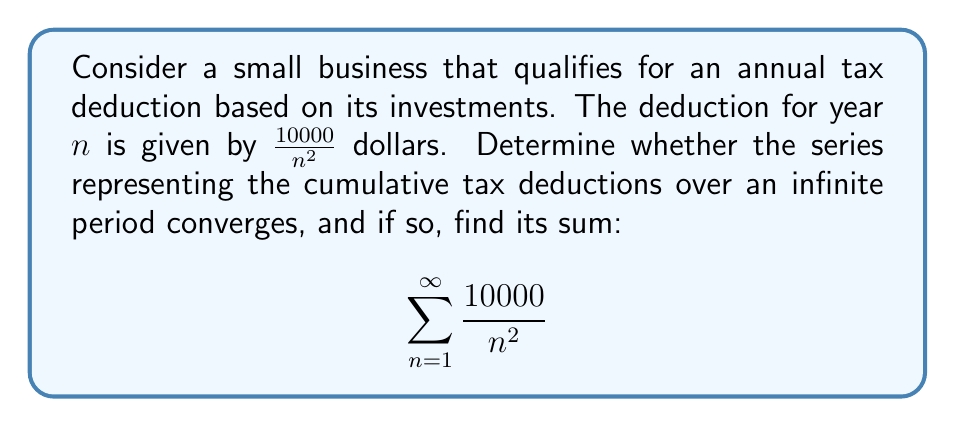Help me with this question. To analyze the convergence of this series, we can follow these steps:

1) First, recognize that this series is a scalar multiple of the p-series $\sum_{n=1}^{\infty} \frac{1}{n^p}$ with $p=2$.

2) Recall that the p-series converges for $p > 1$ and diverges for $p \leq 1$.

3) In this case, $p = 2 > 1$, so the series converges.

4) To find the sum, we can use the fact that:

   $$\sum_{n=1}^{\infty} \frac{1}{n^2} = \frac{\pi^2}{6}$$

   This is a well-known result in mathematical analysis.

5) Our series is 10000 times this sum:

   $$10000 \sum_{n=1}^{\infty} \frac{1}{n^2} = 10000 \cdot \frac{\pi^2}{6}$$

6) Simplify:
   
   $$10000 \cdot \frac{\pi^2}{6} = \frac{5000\pi^2}{3} \approx 16449.34$$

Therefore, the series converges, and the total cumulative tax deduction over an infinite period would be $\frac{5000\pi^2}{3}$ dollars, or approximately $16,449.34 dollars.
Answer: The series converges and its sum is $\frac{5000\pi^2}{3}$ dollars (approximately $16,449.34 dollars). 